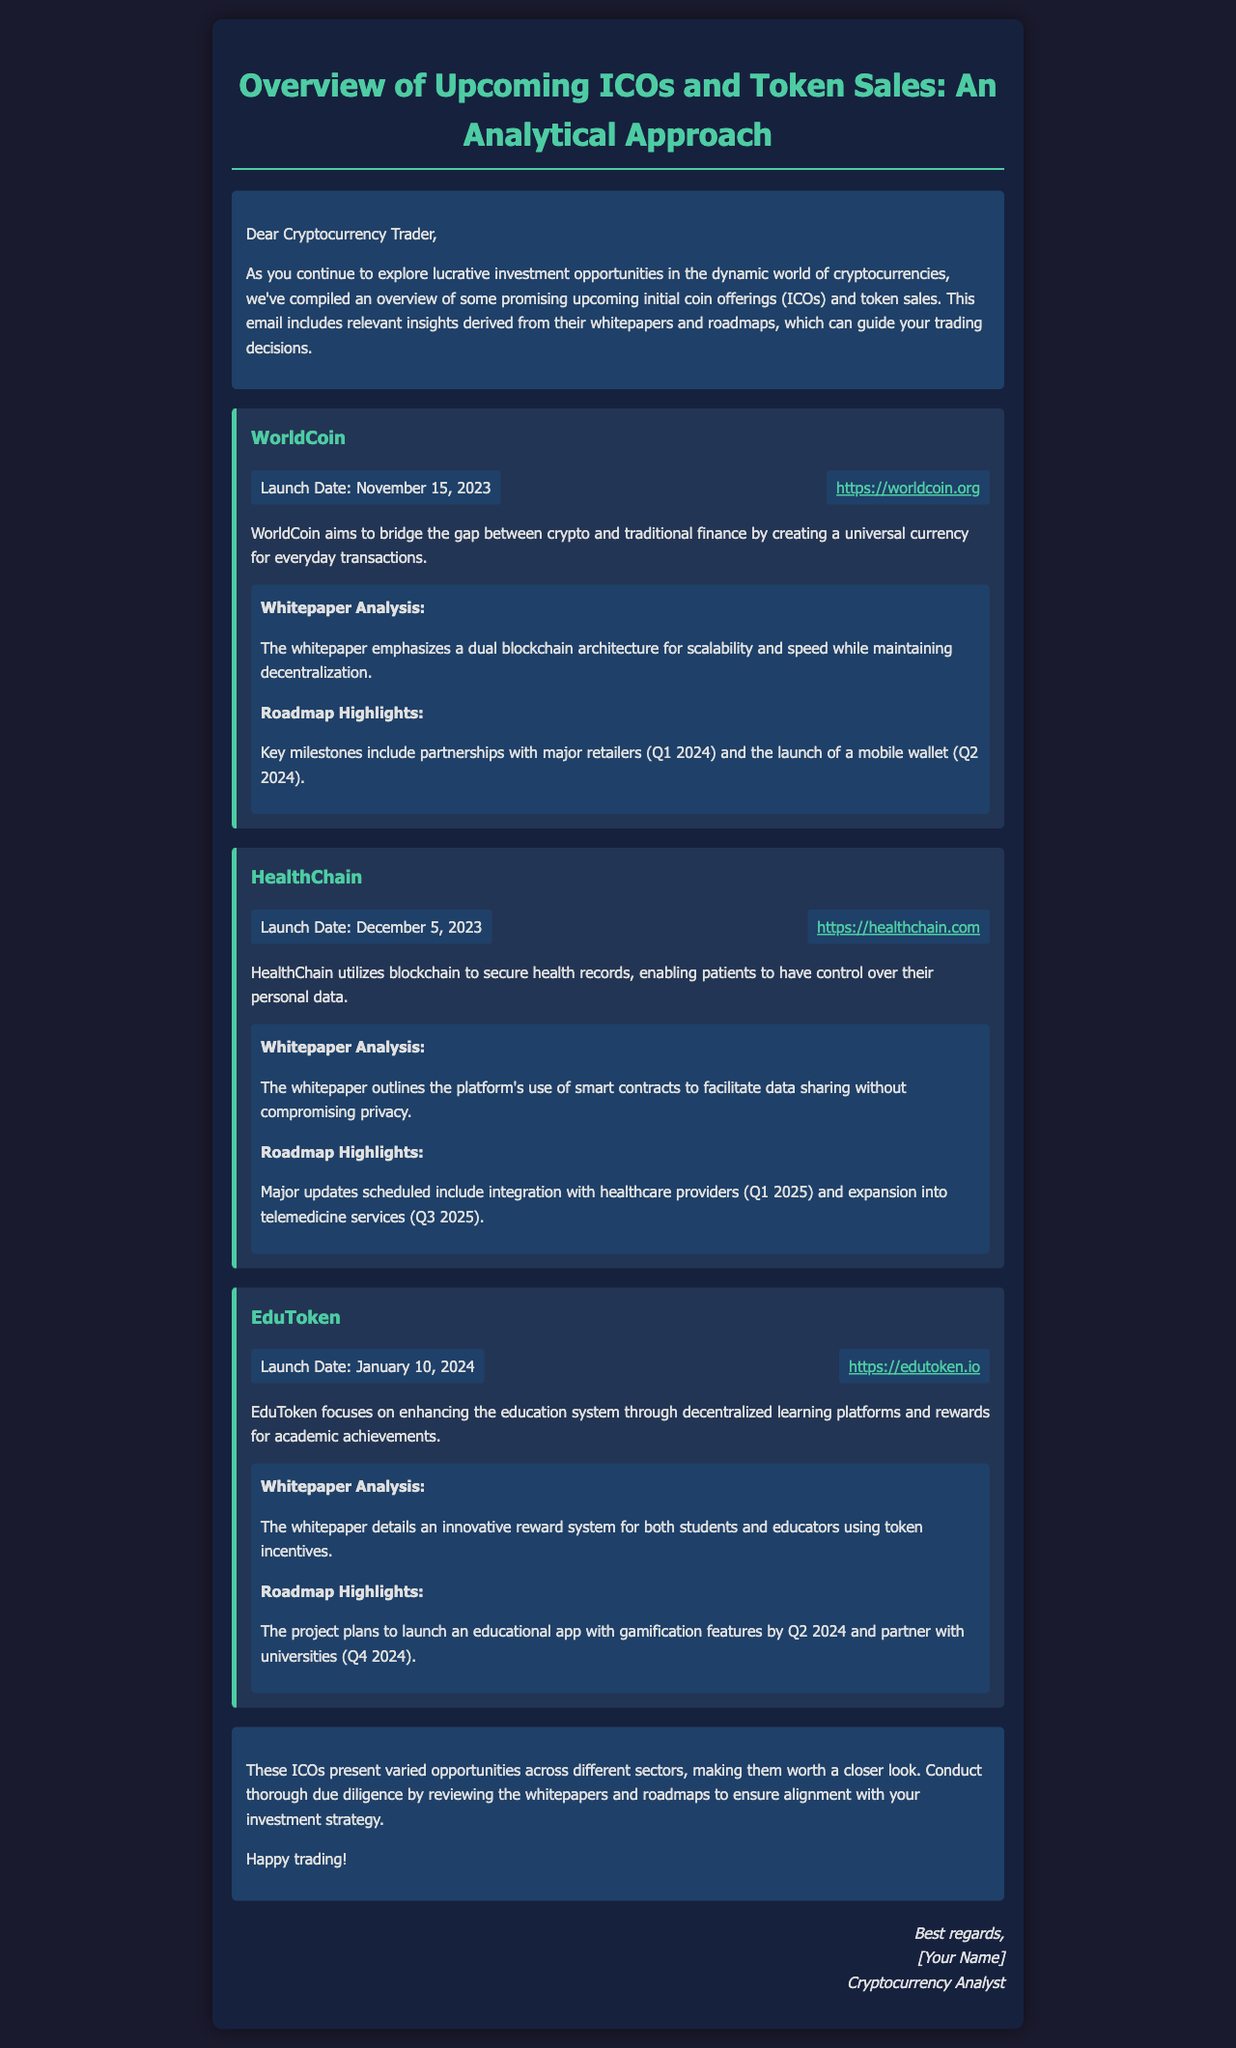What is the launch date of WorldCoin? The launch date of WorldCoin is mentioned in the document.
Answer: November 15, 2023 What is the main aim of HealthChain? The document states that HealthChain utilizes blockchain to secure health records, enabling patients to have control over their personal data.
Answer: Secure health records What are the roadmap highlights for EduToken? The roadmap highlights are provided for EduToken in the document.
Answer: Launch educational app with gamification features by Q2 2024 What is the primary technology used by HealthChain? The whitepaper analysis for HealthChain outlines its use of smart contracts.
Answer: Smart contracts What does WorldCoin aim to bridge? WorldCoin's aim is specified in its description within the document.
Answer: Gap between crypto and traditional finance What is included in the conclusion of the document? The conclusion summarizes the value of ICOs and advises on due diligence.
Answer: Conduct thorough due diligence What is the color of the ICO background section? The document describes the background color of the ICO section.
Answer: #233554 What is the website for EduToken? The document provides a specific URL for EduToken.
Answer: https://edutoken.io 